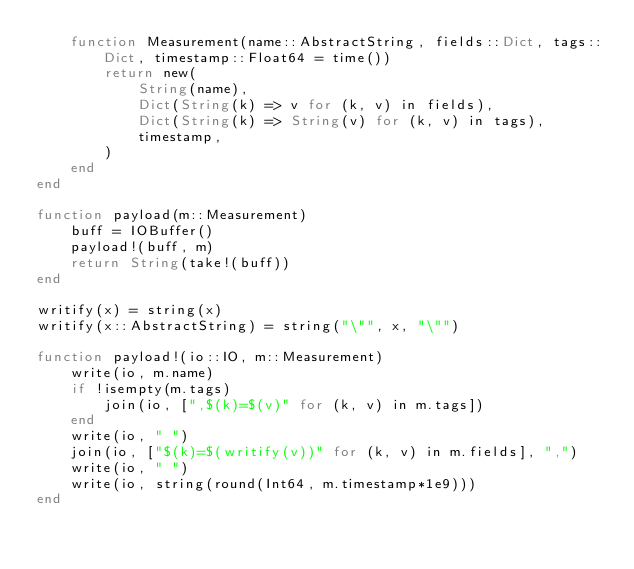<code> <loc_0><loc_0><loc_500><loc_500><_Julia_>    function Measurement(name::AbstractString, fields::Dict, tags::Dict, timestamp::Float64 = time())
        return new(
            String(name),
            Dict(String(k) => v for (k, v) in fields),
            Dict(String(k) => String(v) for (k, v) in tags),
            timestamp,
        )
    end
end

function payload(m::Measurement)
    buff = IOBuffer()
    payload!(buff, m)
    return String(take!(buff))
end

writify(x) = string(x)
writify(x::AbstractString) = string("\"", x, "\"")

function payload!(io::IO, m::Measurement)
    write(io, m.name)
    if !isempty(m.tags)
        join(io, [",$(k)=$(v)" for (k, v) in m.tags])
    end
    write(io, " ")
    join(io, ["$(k)=$(writify(v))" for (k, v) in m.fields], ",")
    write(io, " ")
    write(io, string(round(Int64, m.timestamp*1e9)))
end
</code> 